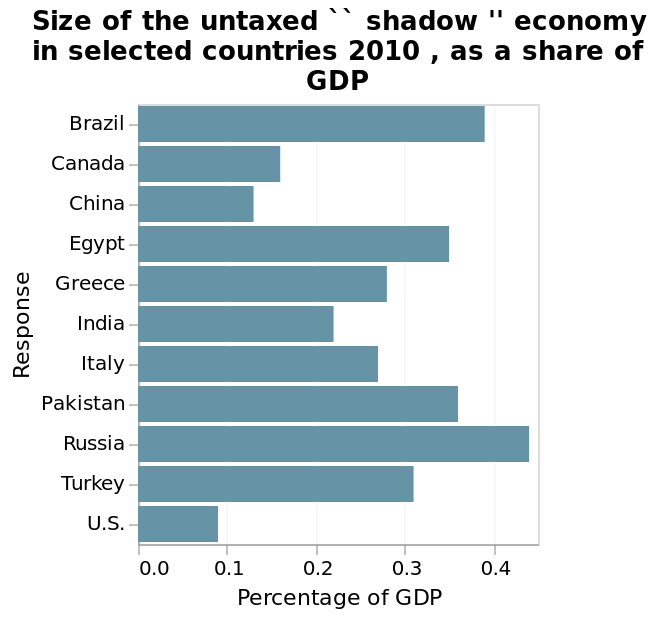<image>
What does the y-axis represent in the bar plot?  The y-axis represents the categorical scale from Brazil to U.S., labeled as "Response." please summary the statistics and relations of the chart Russia has the largest untaxed ‘shadow’ economy and the US has the least, from the responses given. The difference between Russia and the US in terms of the percentage of GDP the ‘shadow’ economy takes up is about 0.4. What does the bar plot measure as a share of GDP? The bar plot measures the size of the untaxed 'shadow' economy as a share of GDP in selected countries. 